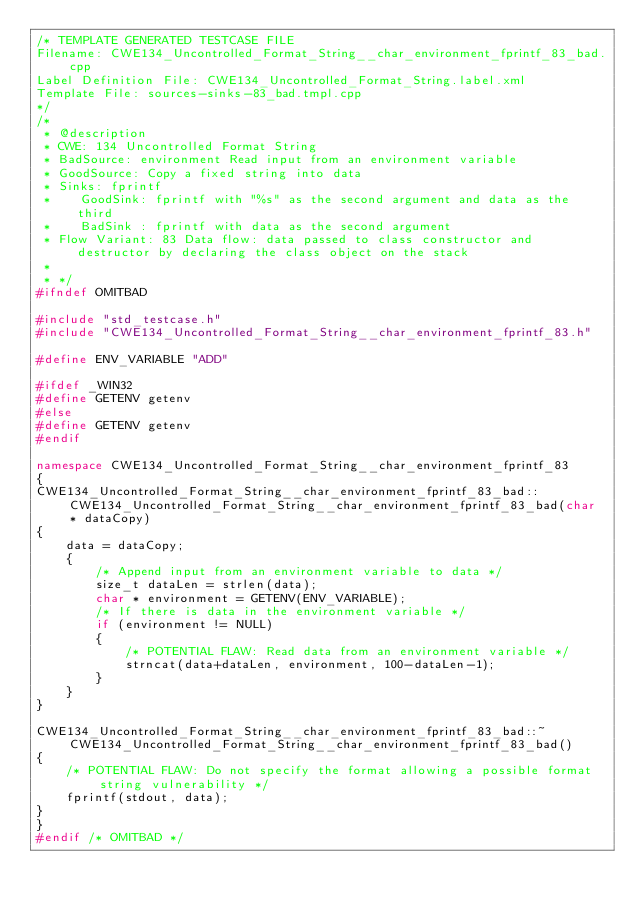Convert code to text. <code><loc_0><loc_0><loc_500><loc_500><_C++_>/* TEMPLATE GENERATED TESTCASE FILE
Filename: CWE134_Uncontrolled_Format_String__char_environment_fprintf_83_bad.cpp
Label Definition File: CWE134_Uncontrolled_Format_String.label.xml
Template File: sources-sinks-83_bad.tmpl.cpp
*/
/*
 * @description
 * CWE: 134 Uncontrolled Format String
 * BadSource: environment Read input from an environment variable
 * GoodSource: Copy a fixed string into data
 * Sinks: fprintf
 *    GoodSink: fprintf with "%s" as the second argument and data as the third
 *    BadSink : fprintf with data as the second argument
 * Flow Variant: 83 Data flow: data passed to class constructor and destructor by declaring the class object on the stack
 *
 * */
#ifndef OMITBAD

#include "std_testcase.h"
#include "CWE134_Uncontrolled_Format_String__char_environment_fprintf_83.h"

#define ENV_VARIABLE "ADD"

#ifdef _WIN32
#define GETENV getenv
#else
#define GETENV getenv
#endif

namespace CWE134_Uncontrolled_Format_String__char_environment_fprintf_83
{
CWE134_Uncontrolled_Format_String__char_environment_fprintf_83_bad::CWE134_Uncontrolled_Format_String__char_environment_fprintf_83_bad(char * dataCopy)
{
    data = dataCopy;
    {
        /* Append input from an environment variable to data */
        size_t dataLen = strlen(data);
        char * environment = GETENV(ENV_VARIABLE);
        /* If there is data in the environment variable */
        if (environment != NULL)
        {
            /* POTENTIAL FLAW: Read data from an environment variable */
            strncat(data+dataLen, environment, 100-dataLen-1);
        }
    }
}

CWE134_Uncontrolled_Format_String__char_environment_fprintf_83_bad::~CWE134_Uncontrolled_Format_String__char_environment_fprintf_83_bad()
{
    /* POTENTIAL FLAW: Do not specify the format allowing a possible format string vulnerability */
    fprintf(stdout, data);
}
}
#endif /* OMITBAD */
</code> 